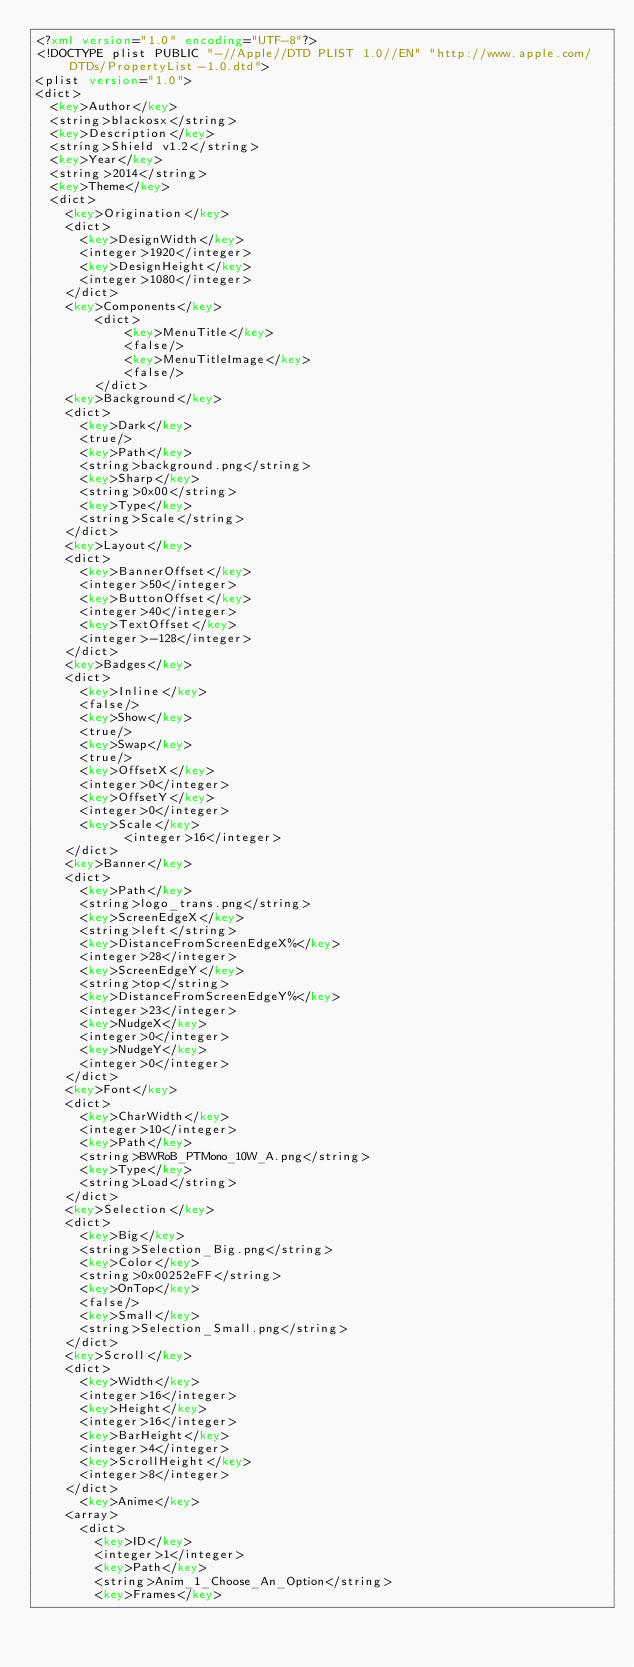Convert code to text. <code><loc_0><loc_0><loc_500><loc_500><_XML_><?xml version="1.0" encoding="UTF-8"?>
<!DOCTYPE plist PUBLIC "-//Apple//DTD PLIST 1.0//EN" "http://www.apple.com/DTDs/PropertyList-1.0.dtd">
<plist version="1.0">
<dict>
	<key>Author</key>
	<string>blackosx</string>
	<key>Description</key>
	<string>Shield v1.2</string>
	<key>Year</key>
	<string>2014</string>
	<key>Theme</key>
	<dict>
		<key>Origination</key>
		<dict>
			<key>DesignWidth</key>
			<integer>1920</integer>
			<key>DesignHeight</key>
			<integer>1080</integer>
		</dict>
		<key>Components</key>
        <dict>
            <key>MenuTitle</key>
            <false/>
            <key>MenuTitleImage</key>
            <false/>
        </dict>
		<key>Background</key>
		<dict>
			<key>Dark</key>
			<true/>
			<key>Path</key>
			<string>background.png</string>
			<key>Sharp</key>
			<string>0x00</string>
			<key>Type</key>
			<string>Scale</string>
		</dict>
		<key>Layout</key>
		<dict>
			<key>BannerOffset</key>
			<integer>50</integer>
			<key>ButtonOffset</key>
			<integer>40</integer>
			<key>TextOffset</key>
			<integer>-128</integer>
		</dict>
		<key>Badges</key>
		<dict>
			<key>Inline</key>
			<false/>
			<key>Show</key>
			<true/>
			<key>Swap</key>
			<true/>
			<key>OffsetX</key>
			<integer>0</integer>
			<key>OffsetY</key>
			<integer>0</integer>
			<key>Scale</key>
            <integer>16</integer>
		</dict>
		<key>Banner</key>
		<dict>
			<key>Path</key>
			<string>logo_trans.png</string>
			<key>ScreenEdgeX</key>
			<string>left</string>
			<key>DistanceFromScreenEdgeX%</key>
			<integer>28</integer>
			<key>ScreenEdgeY</key>
			<string>top</string>
			<key>DistanceFromScreenEdgeY%</key>
			<integer>23</integer>
			<key>NudgeX</key>
			<integer>0</integer>
			<key>NudgeY</key>
			<integer>0</integer>
		</dict>
		<key>Font</key>
		<dict>
			<key>CharWidth</key>
			<integer>10</integer>
			<key>Path</key>
			<string>BWRoB_PTMono_10W_A.png</string>
			<key>Type</key>
			<string>Load</string>
		</dict>
		<key>Selection</key>
		<dict>
			<key>Big</key>
			<string>Selection_Big.png</string>
			<key>Color</key>
			<string>0x00252eFF</string>
			<key>OnTop</key>
			<false/>
			<key>Small</key>
			<string>Selection_Small.png</string>
		</dict>
		<key>Scroll</key>
		<dict>
			<key>Width</key>
			<integer>16</integer> 
			<key>Height</key>
			<integer>16</integer>
			<key>BarHeight</key>
			<integer>4</integer>
			<key>ScrollHeight</key>
			<integer>8</integer>
		</dict>
	    <key>Anime</key>
		<array>
			<dict>
				<key>ID</key>
				<integer>1</integer>
				<key>Path</key>
				<string>Anim_1_Choose_An_Option</string>
				<key>Frames</key></code> 